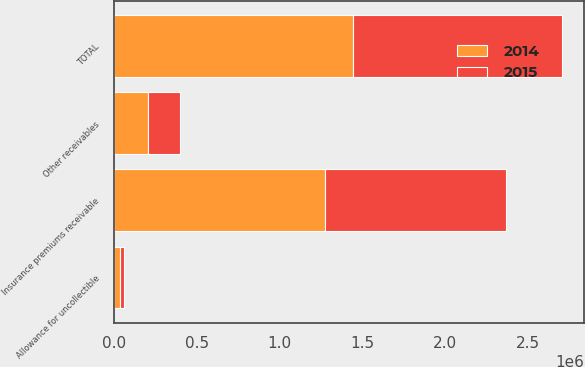<chart> <loc_0><loc_0><loc_500><loc_500><stacked_bar_chart><ecel><fcel>Insurance premiums receivable<fcel>Other receivables<fcel>Allowance for uncollectible<fcel>TOTAL<nl><fcel>2015<fcel>1.09214e+06<fcel>196277<fcel>27696<fcel>1.26072e+06<nl><fcel>2014<fcel>1.27544e+06<fcel>201758<fcel>31568<fcel>1.44563e+06<nl></chart> 